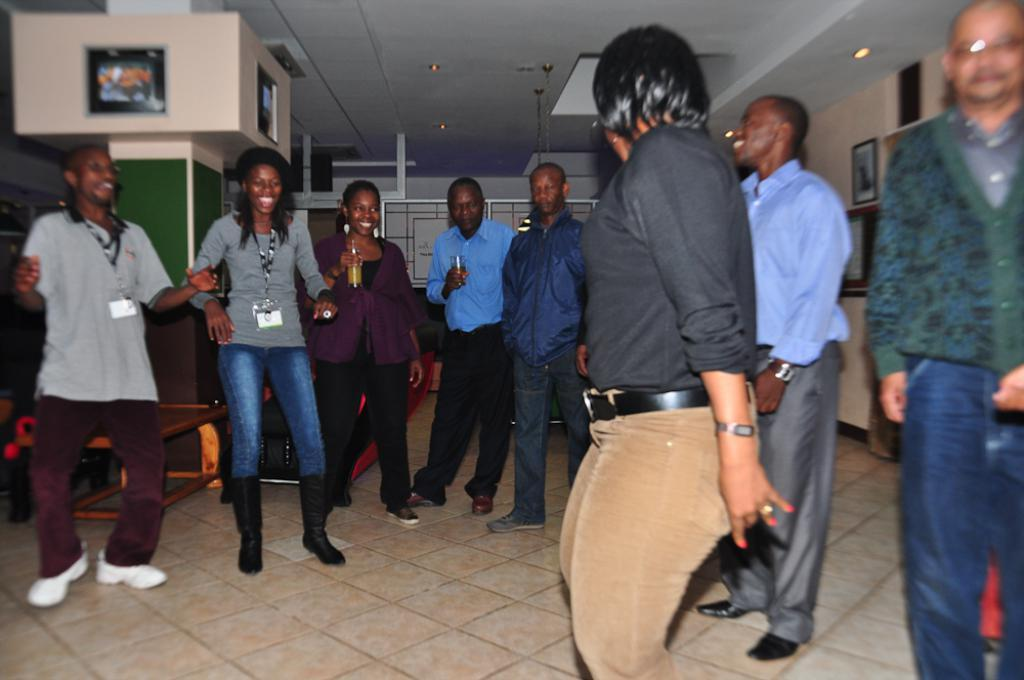How many people are in the group in the image? There is a group of people in the image, but the exact number cannot be determined from the provided facts. What are the people in the group doing? The people are on the floor, and some of them are smiling. What can be seen in the background of the image? In the background of the image, there is a table, frames, lights, and other objects. Can you describe the lighting in the image? The presence of lights in the background suggests that the image is well-lit. What type of bubble is being used to cover the people in the image? There is no bubble present in the image, and therefore no such covering can be observed. 